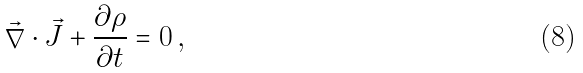<formula> <loc_0><loc_0><loc_500><loc_500>\vec { \nabla } \cdot \vec { J } + \frac { \partial \rho } { \partial t } = 0 \, ,</formula> 